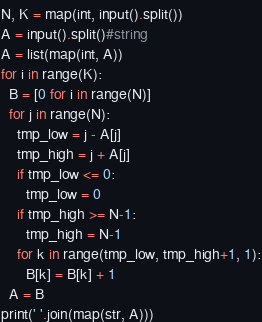<code> <loc_0><loc_0><loc_500><loc_500><_Python_>N, K = map(int, input().split())
A = input().split()#string
A = list(map(int, A))
for i in range(K):
  B = [0 for i in range(N)]
  for j in range(N):
    tmp_low = j - A[j] 
    tmp_high = j + A[j] 
    if tmp_low <= 0:
      tmp_low = 0
    if tmp_high >= N-1:
      tmp_high = N-1
    for k in range(tmp_low, tmp_high+1, 1):
      B[k] = B[k] + 1
  A = B
print(' '.join(map(str, A)))</code> 